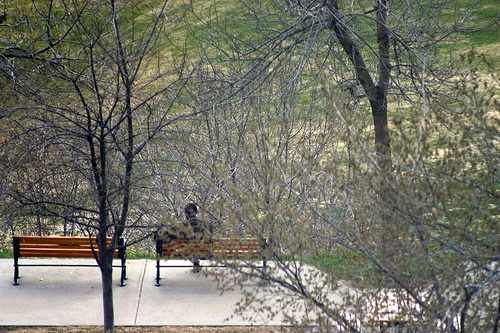Describe the objects in this image and their specific colors. I can see bench in darkgreen, gray, maroon, black, and ivory tones, bench in darkgreen, maroon, black, navy, and khaki tones, and people in darkgreen, gray, and black tones in this image. 